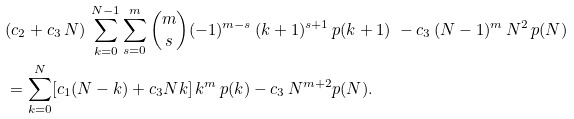Convert formula to latex. <formula><loc_0><loc_0><loc_500><loc_500>& ( c _ { 2 } + c _ { 3 } \, N ) \, \sum _ { k = 0 } ^ { N - 1 } \sum _ { s = 0 } ^ { m } \binom { m } { s } ( - 1 ) ^ { m - s } \, ( k + 1 ) ^ { s + 1 } \, p ( k + 1 ) \ - c _ { 3 } \, ( N - 1 ) ^ { m } \, N ^ { 2 } \, p ( N ) \\ & = \sum _ { k = 0 } ^ { N } [ c _ { 1 } ( N - k ) + c _ { 3 } N k ] \, k ^ { m } \, p ( k ) - c _ { 3 } \, N ^ { m + 2 } p ( N ) .</formula> 